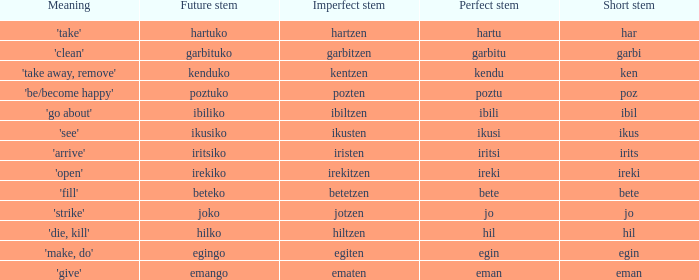What is the short stem for garbitzen? Garbi. 